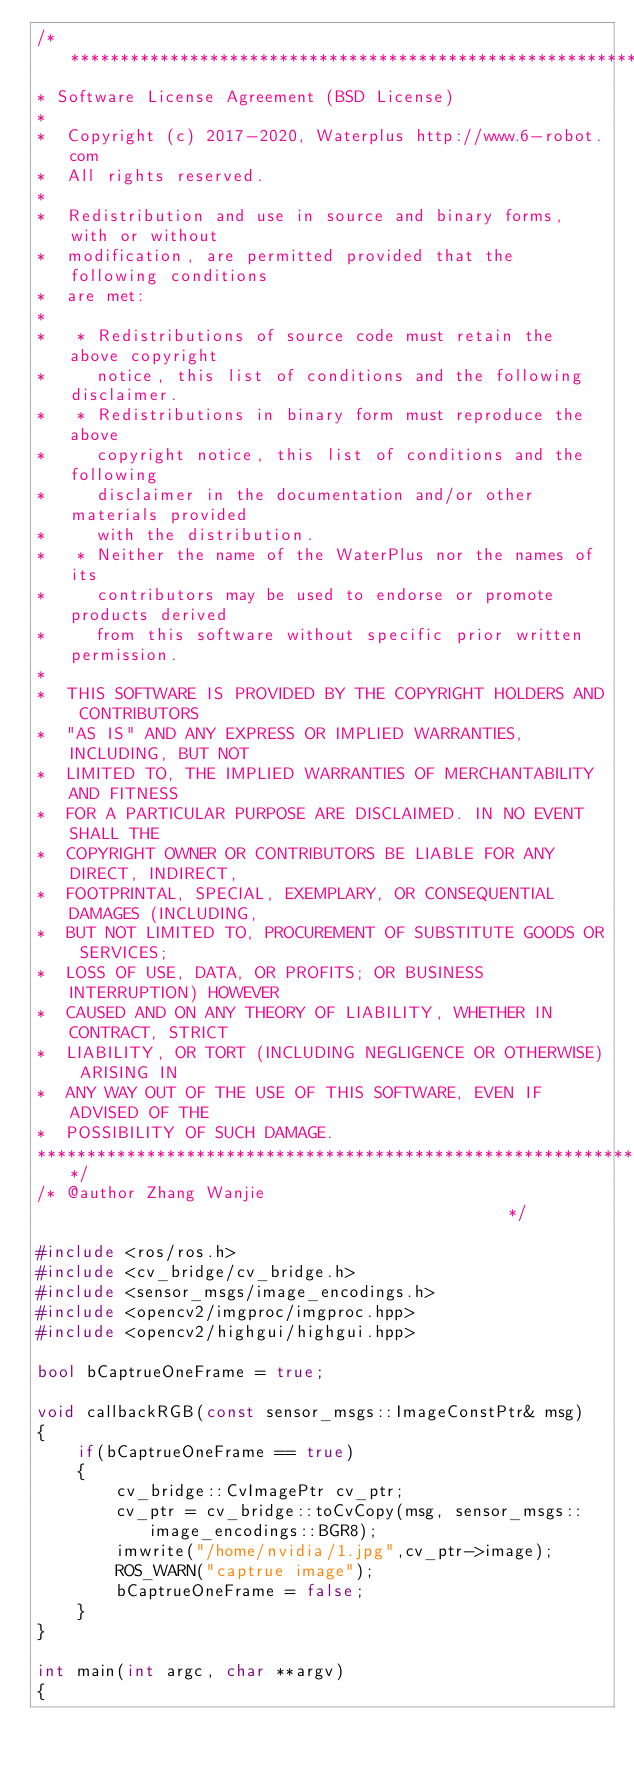Convert code to text. <code><loc_0><loc_0><loc_500><loc_500><_C++_>/*********************************************************************
* Software License Agreement (BSD License)
* 
*  Copyright (c) 2017-2020, Waterplus http://www.6-robot.com
*  All rights reserved.
* 
*  Redistribution and use in source and binary forms, with or without
*  modification, are permitted provided that the following conditions
*  are met:
* 
*   * Redistributions of source code must retain the above copyright
*     notice, this list of conditions and the following disclaimer.
*   * Redistributions in binary form must reproduce the above
*     copyright notice, this list of conditions and the following
*     disclaimer in the documentation and/or other materials provided
*     with the distribution.
*   * Neither the name of the WaterPlus nor the names of its
*     contributors may be used to endorse or promote products derived
*     from this software without specific prior written permission.
* 
*  THIS SOFTWARE IS PROVIDED BY THE COPYRIGHT HOLDERS AND CONTRIBUTORS
*  "AS IS" AND ANY EXPRESS OR IMPLIED WARRANTIES, INCLUDING, BUT NOT
*  LIMITED TO, THE IMPLIED WARRANTIES OF MERCHANTABILITY AND FITNESS
*  FOR A PARTICULAR PURPOSE ARE DISCLAIMED. IN NO EVENT SHALL THE
*  COPYRIGHT OWNER OR CONTRIBUTORS BE LIABLE FOR ANY DIRECT, INDIRECT,
*  FOOTPRINTAL, SPECIAL, EXEMPLARY, OR CONSEQUENTIAL DAMAGES (INCLUDING,
*  BUT NOT LIMITED TO, PROCUREMENT OF SUBSTITUTE GOODS OR SERVICES;
*  LOSS OF USE, DATA, OR PROFITS; OR BUSINESS INTERRUPTION) HOWEVER
*  CAUSED AND ON ANY THEORY OF LIABILITY, WHETHER IN CONTRACT, STRICT
*  LIABILITY, OR TORT (INCLUDING NEGLIGENCE OR OTHERWISE) ARISING IN
*  ANY WAY OUT OF THE USE OF THIS SOFTWARE, EVEN IF ADVISED OF THE
*  POSSIBILITY OF SUCH DAMAGE.
*********************************************************************/
/* @author Zhang Wanjie                                             */

#include <ros/ros.h>
#include <cv_bridge/cv_bridge.h>
#include <sensor_msgs/image_encodings.h>
#include <opencv2/imgproc/imgproc.hpp>
#include <opencv2/highgui/highgui.hpp>

bool bCaptrueOneFrame = true;

void callbackRGB(const sensor_msgs::ImageConstPtr& msg)
{
    if(bCaptrueOneFrame == true)
    {
        cv_bridge::CvImagePtr cv_ptr;
        cv_ptr = cv_bridge::toCvCopy(msg, sensor_msgs::image_encodings::BGR8);
        imwrite("/home/nvidia/1.jpg",cv_ptr->image);
        ROS_WARN("captrue image");
        bCaptrueOneFrame = false;
    }
}

int main(int argc, char **argv)
{</code> 